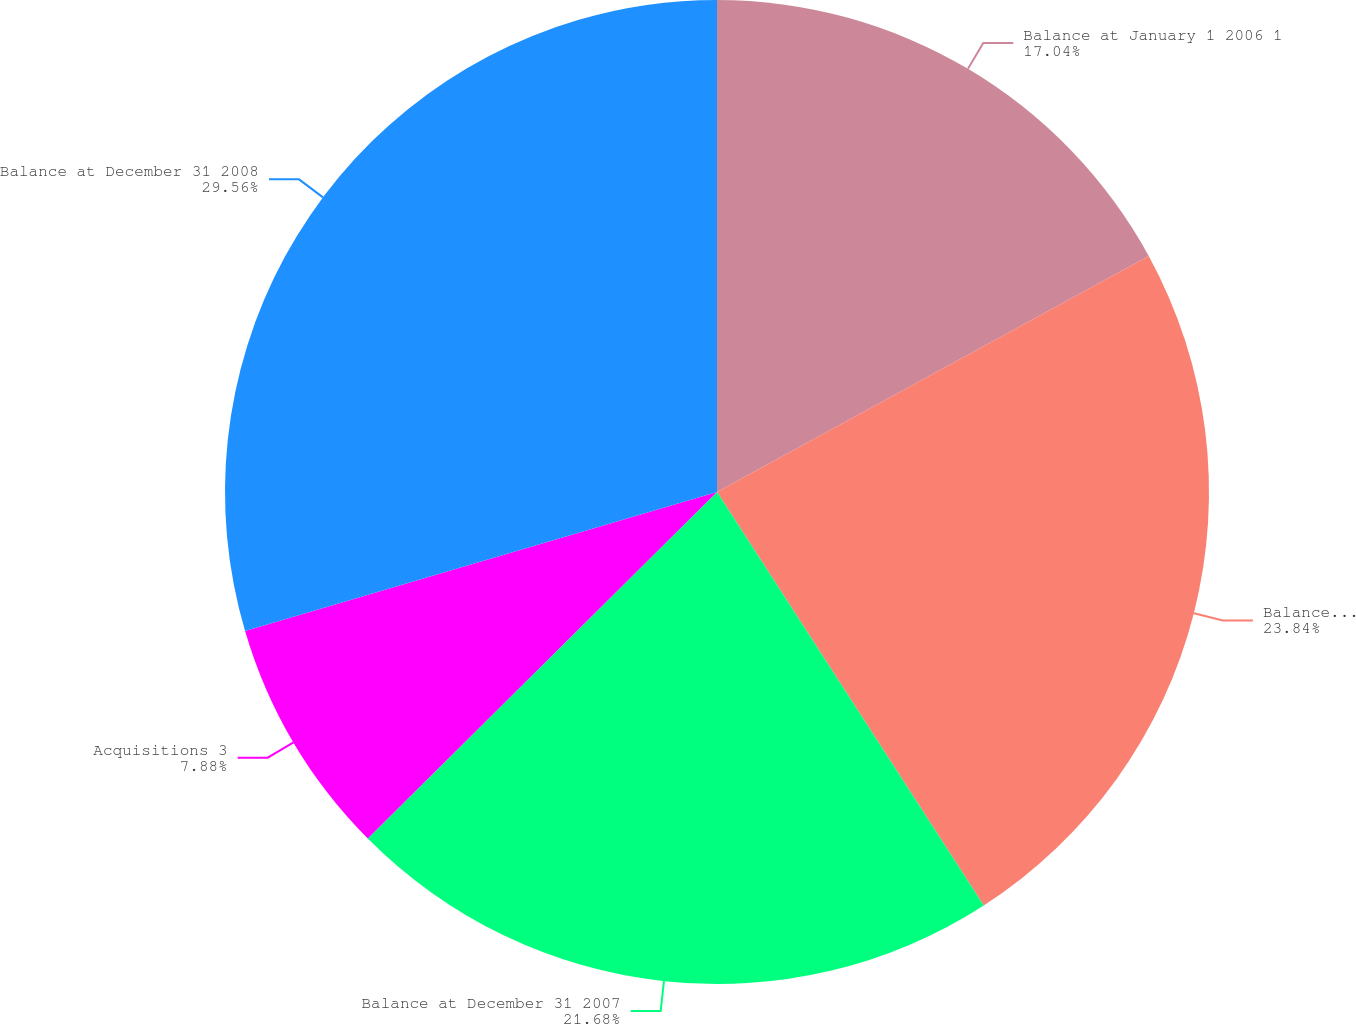Convert chart to OTSL. <chart><loc_0><loc_0><loc_500><loc_500><pie_chart><fcel>Balance at January 1 2006 1<fcel>Balance at December 31 2006<fcel>Balance at December 31 2007<fcel>Acquisitions 3<fcel>Balance at December 31 2008<nl><fcel>17.04%<fcel>23.84%<fcel>21.68%<fcel>7.88%<fcel>29.56%<nl></chart> 